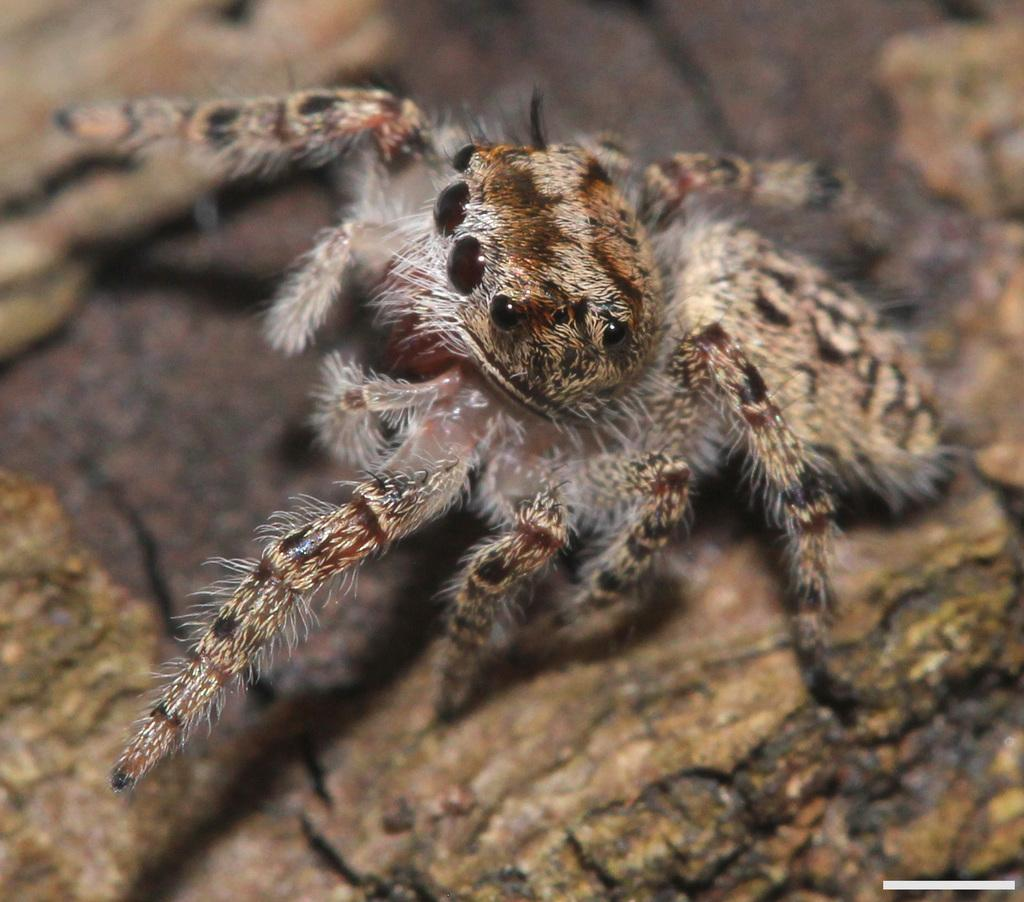What is the main subject of the image? The main subject of the image is a wolf spider. What type of zinc is used to create the bead that the wolf spider is holding with the wrench? There is no zinc, bead, or wrench present in the image. The image only features a wolf spider. 